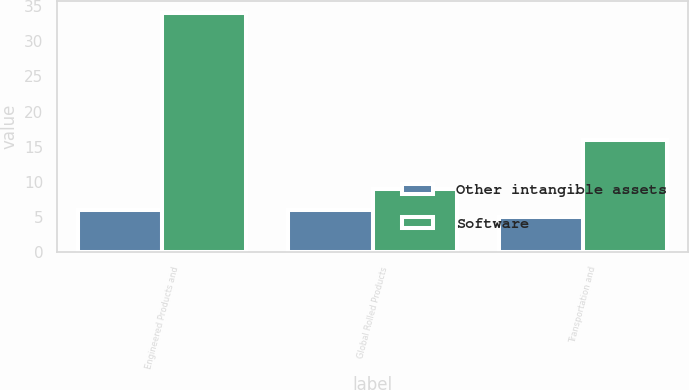<chart> <loc_0><loc_0><loc_500><loc_500><stacked_bar_chart><ecel><fcel>Engineered Products and<fcel>Global Rolled Products<fcel>Transportation and<nl><fcel>Other intangible assets<fcel>6<fcel>6<fcel>5<nl><fcel>Software<fcel>34<fcel>9<fcel>16<nl></chart> 